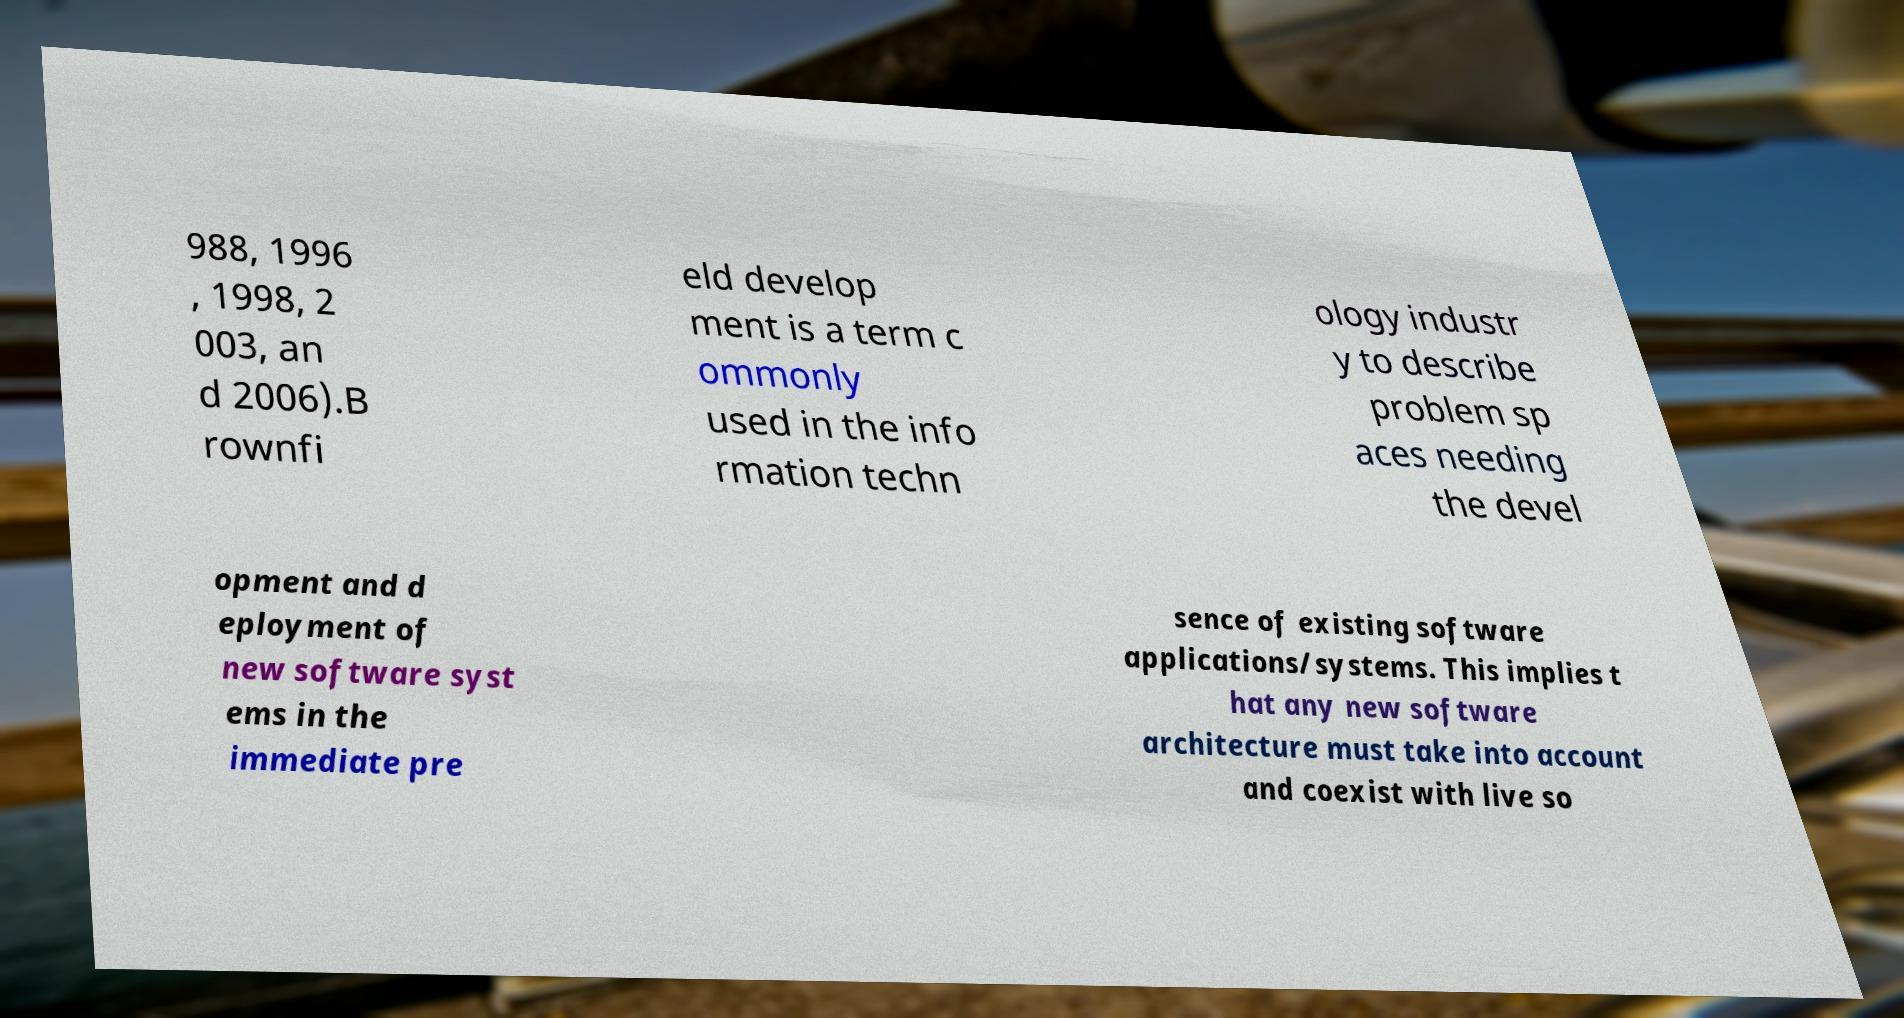Can you read and provide the text displayed in the image?This photo seems to have some interesting text. Can you extract and type it out for me? 988, 1996 , 1998, 2 003, an d 2006).B rownfi eld develop ment is a term c ommonly used in the info rmation techn ology industr y to describe problem sp aces needing the devel opment and d eployment of new software syst ems in the immediate pre sence of existing software applications/systems. This implies t hat any new software architecture must take into account and coexist with live so 